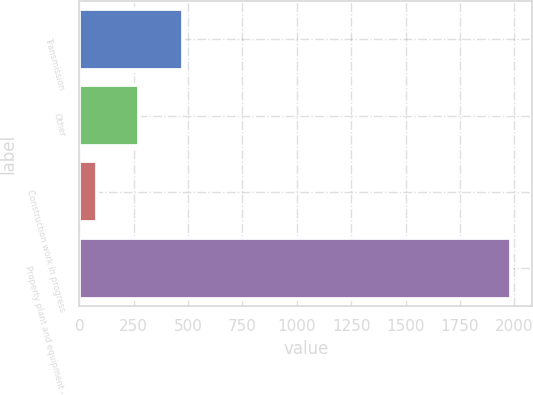Convert chart. <chart><loc_0><loc_0><loc_500><loc_500><bar_chart><fcel>Transmission<fcel>Other<fcel>Construction work in progress<fcel>Property plant and equipment -<nl><fcel>476<fcel>272.1<fcel>82<fcel>1983<nl></chart> 